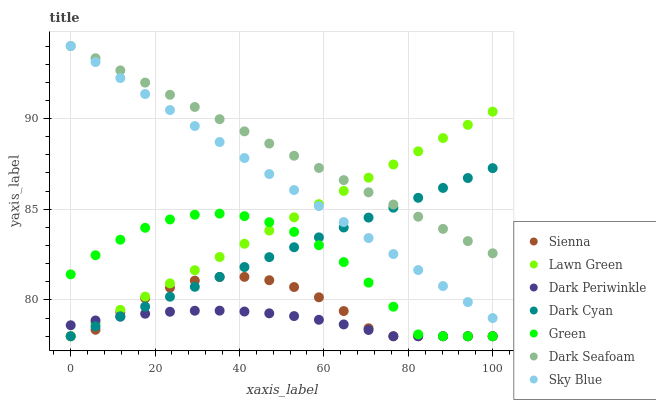Does Dark Periwinkle have the minimum area under the curve?
Answer yes or no. Yes. Does Dark Seafoam have the maximum area under the curve?
Answer yes or no. Yes. Does Sienna have the minimum area under the curve?
Answer yes or no. No. Does Sienna have the maximum area under the curve?
Answer yes or no. No. Is Lawn Green the smoothest?
Answer yes or no. Yes. Is Green the roughest?
Answer yes or no. Yes. Is Sienna the smoothest?
Answer yes or no. No. Is Sienna the roughest?
Answer yes or no. No. Does Lawn Green have the lowest value?
Answer yes or no. Yes. Does Dark Seafoam have the lowest value?
Answer yes or no. No. Does Sky Blue have the highest value?
Answer yes or no. Yes. Does Sienna have the highest value?
Answer yes or no. No. Is Green less than Sky Blue?
Answer yes or no. Yes. Is Sky Blue greater than Dark Periwinkle?
Answer yes or no. Yes. Does Sky Blue intersect Lawn Green?
Answer yes or no. Yes. Is Sky Blue less than Lawn Green?
Answer yes or no. No. Is Sky Blue greater than Lawn Green?
Answer yes or no. No. Does Green intersect Sky Blue?
Answer yes or no. No. 